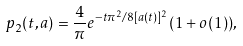<formula> <loc_0><loc_0><loc_500><loc_500>p _ { 2 } ( t , a ) = \frac { 4 } { \pi } e ^ { - t \pi ^ { 2 } / 8 [ a ( t ) ] ^ { 2 } } ( 1 + o ( 1 ) ) ,</formula> 